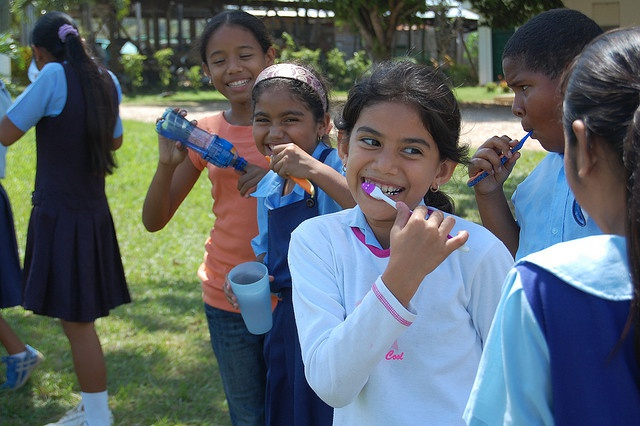Describe the objects in this image and their specific colors. I can see people in teal, lightblue, and gray tones, people in teal, navy, black, lightblue, and gray tones, people in teal, black, and gray tones, people in teal, brown, gray, black, and maroon tones, and people in teal, black, gray, navy, and blue tones in this image. 